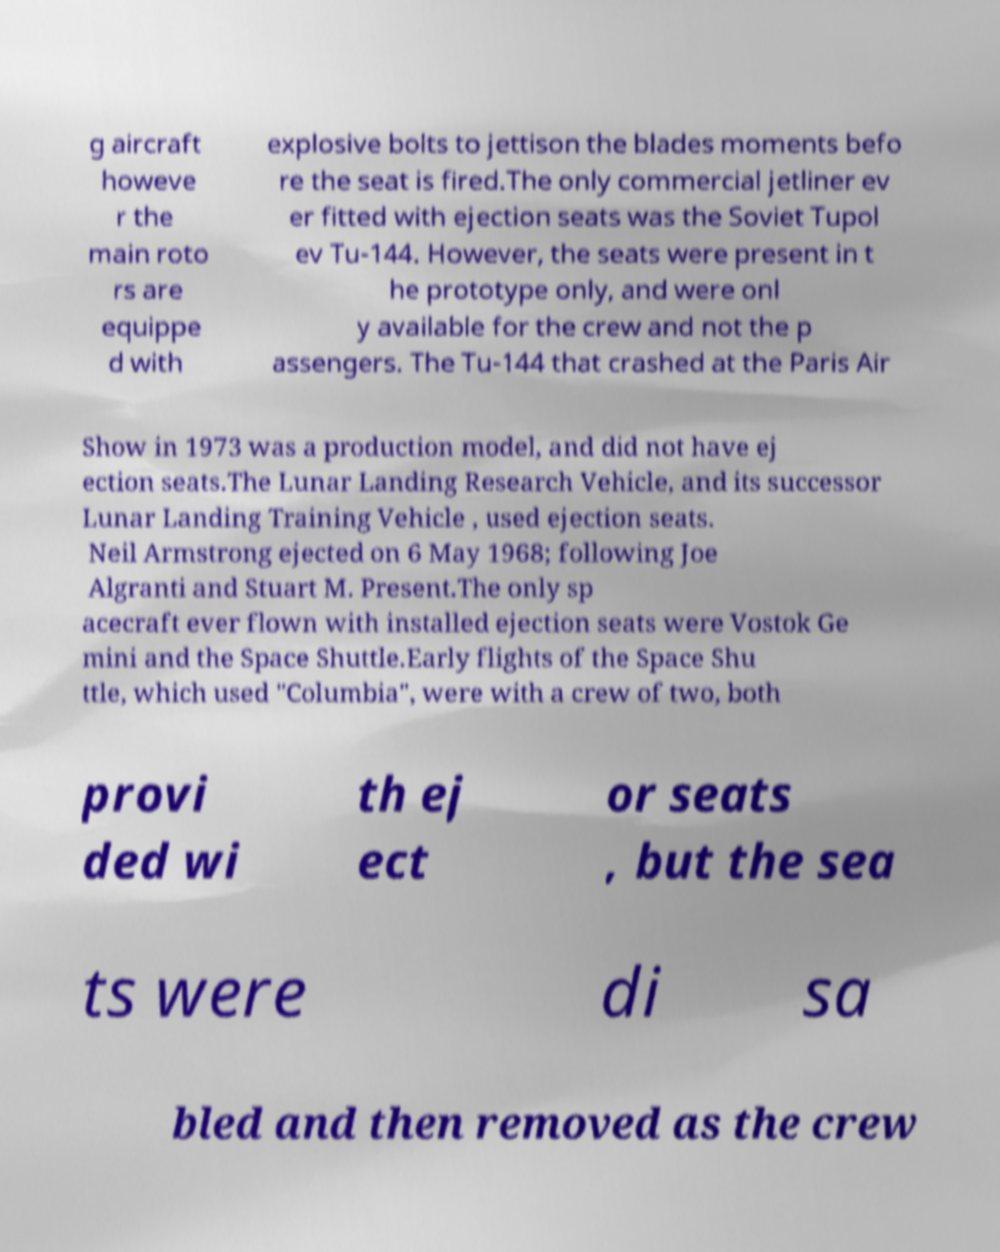Please identify and transcribe the text found in this image. g aircraft howeve r the main roto rs are equippe d with explosive bolts to jettison the blades moments befo re the seat is fired.The only commercial jetliner ev er fitted with ejection seats was the Soviet Tupol ev Tu-144. However, the seats were present in t he prototype only, and were onl y available for the crew and not the p assengers. The Tu-144 that crashed at the Paris Air Show in 1973 was a production model, and did not have ej ection seats.The Lunar Landing Research Vehicle, and its successor Lunar Landing Training Vehicle , used ejection seats. Neil Armstrong ejected on 6 May 1968; following Joe Algranti and Stuart M. Present.The only sp acecraft ever flown with installed ejection seats were Vostok Ge mini and the Space Shuttle.Early flights of the Space Shu ttle, which used "Columbia", were with a crew of two, both provi ded wi th ej ect or seats , but the sea ts were di sa bled and then removed as the crew 